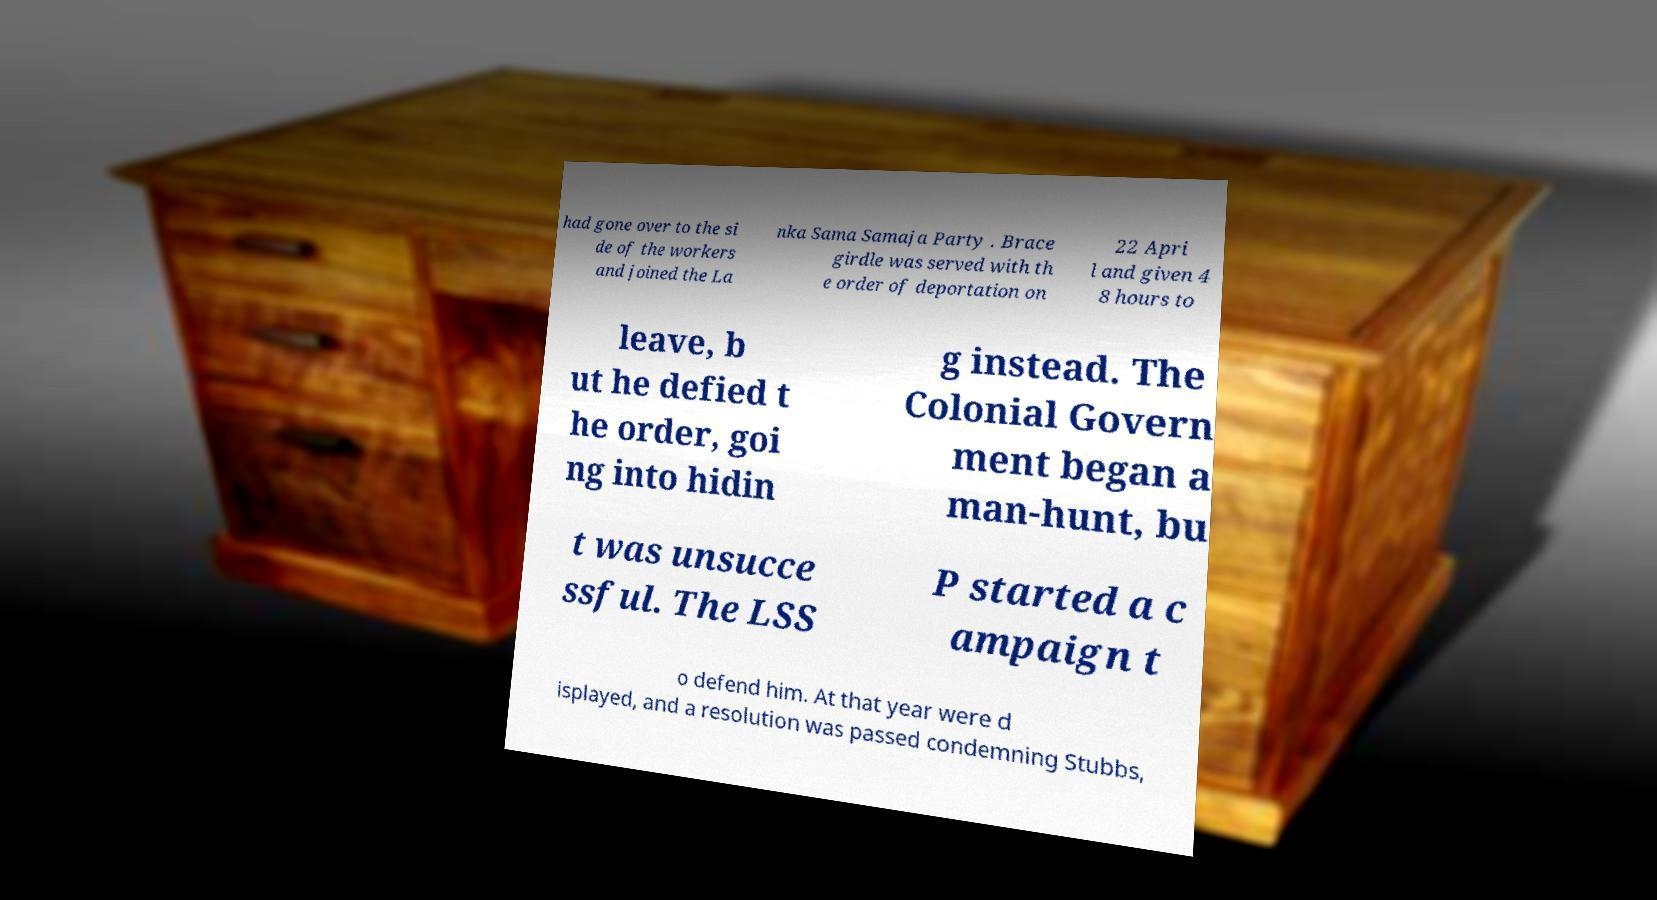Could you extract and type out the text from this image? had gone over to the si de of the workers and joined the La nka Sama Samaja Party . Brace girdle was served with th e order of deportation on 22 Apri l and given 4 8 hours to leave, b ut he defied t he order, goi ng into hidin g instead. The Colonial Govern ment began a man-hunt, bu t was unsucce ssful. The LSS P started a c ampaign t o defend him. At that year were d isplayed, and a resolution was passed condemning Stubbs, 